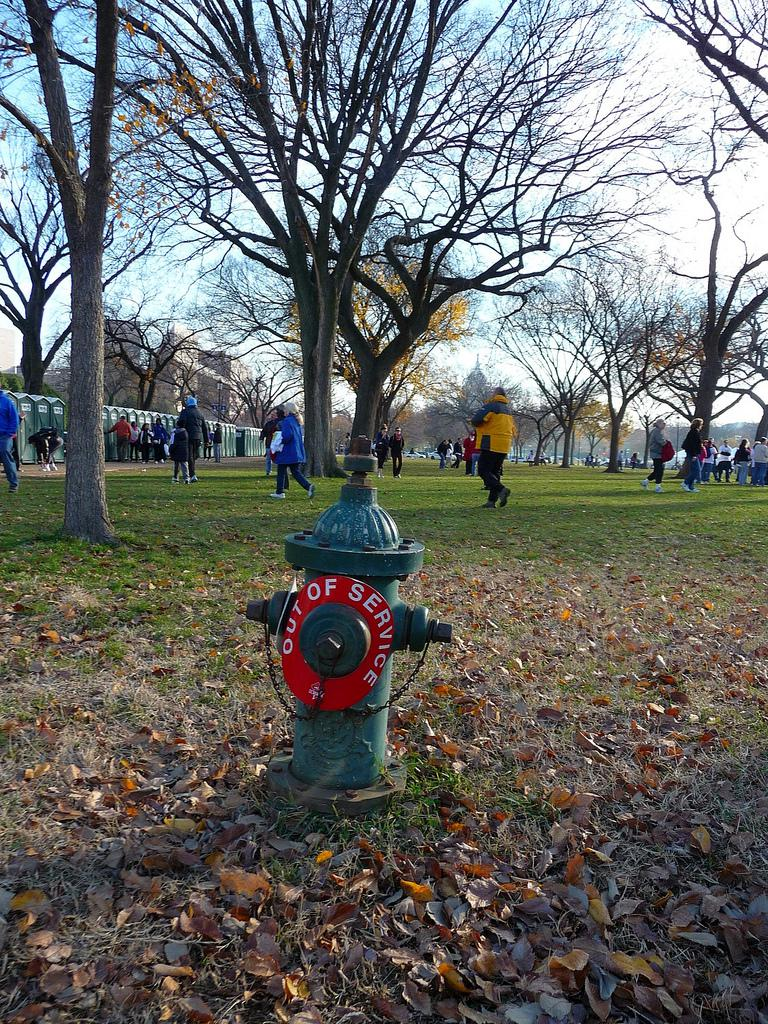Question: how are the branches?
Choices:
A. Hanging.
B. Full.
C. Lush.
D. Bare.
Answer with the letter. Answer: D Question: what small structure appears slightly tilted?
Choices:
A. The fence.
B. The dog house.
C. The fire hydrant.
D. The shed.
Answer with the letter. Answer: C Question: how many leaves are in the distance?
Choices:
A. 2.
B. 7.
C. None.
D. 6.
Answer with the letter. Answer: C Question: when in the year is this photo?
Choices:
A. Fall.
B. Christmas.
C. Spring.
D. Summer.
Answer with the letter. Answer: A Question: what sign is on the fire hydrant?
Choices:
A. Out of service.
B. Do not block.
C. Not an urinal for pets.
D. Fireman use only.
Answer with the letter. Answer: A Question: where are the porta potties?
Choices:
A. At the park.
B. At a race.
C. Next to the monkey exhibit.
D. Left hand side of the picture.
Answer with the letter. Answer: D Question: what color is the hydrant?
Choices:
A. Green.
B. Red.
C. Blue.
D. Yellow.
Answer with the letter. Answer: A Question: what is on fire hydrant?
Choices:
A. Fire Hose.
B. Chain.
C. Fire Extinguisher.
D. A label.
Answer with the letter. Answer: B Question: what is in background?
Choices:
A. Trees.
B. Building with dome room.
C. Ocean.
D. A river.
Answer with the letter. Answer: B Question: what is in the background of the photo?
Choices:
A. A lake.
B. A building.
C. People.
D. Trees.
Answer with the letter. Answer: D Question: how is the weather?
Choices:
A. It is raining.
B. It is cloudy.
C. It is foggy.
D. Bright and sunny.
Answer with the letter. Answer: D Question: who is wearing a yellow jacket?
Choices:
A. A man.
B. A ball player.
C. A little girl.
D. A mommy.
Answer with the letter. Answer: A Question: where is the photo taken?
Choices:
A. At a park.
B. At a school.
C. At a beach.
D. At a house.
Answer with the letter. Answer: A Question: what color are some leaves on the trees?
Choices:
A. Green.
B. Brown.
C. Yellow.
D. Orange.
Answer with the letter. Answer: C Question: what is on ground?
Choices:
A. Grass.
B. Lots of leaves.
C. Flowers.
D. Bushes.
Answer with the letter. Answer: B Question: what are all the people wearing?
Choices:
A. Sandals.
B. Hats.
C. Jackets.
D. Gloves.
Answer with the letter. Answer: C Question: how is the weather?
Choices:
A. Hot.
B. Cold.
C. Warm.
D. Sunny.
Answer with the letter. Answer: B 